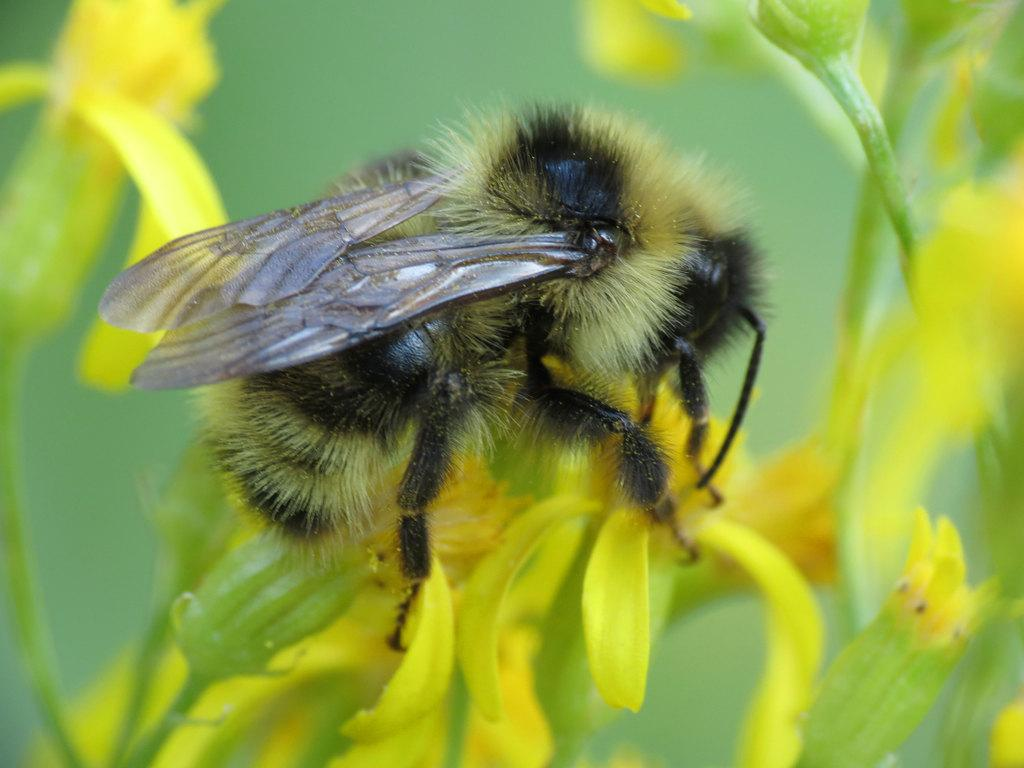What is the main subject in the center of the image? There is a fly in the center of the image. What is the fly sitting on? The fly is on a flower. What type of box can be seen in the image? There is no box present in the image. What is the fly using to brush its teeth in the image? Flies do not have teeth, and there is no toothbrush or any indication of dental care in the image. 